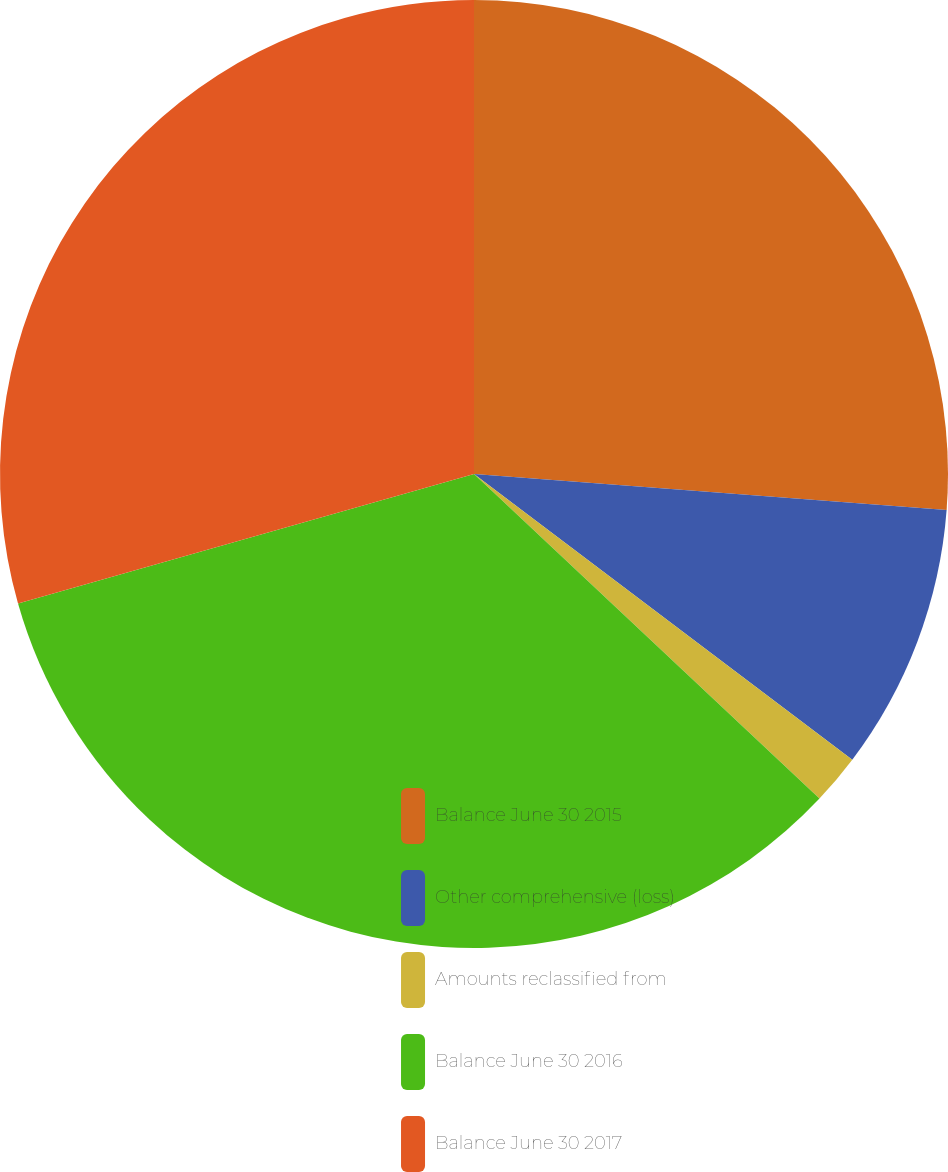<chart> <loc_0><loc_0><loc_500><loc_500><pie_chart><fcel>Balance June 30 2015<fcel>Other comprehensive (loss)<fcel>Amounts reclassified from<fcel>Balance June 30 2016<fcel>Balance June 30 2017<nl><fcel>26.21%<fcel>9.08%<fcel>1.71%<fcel>33.59%<fcel>29.4%<nl></chart> 